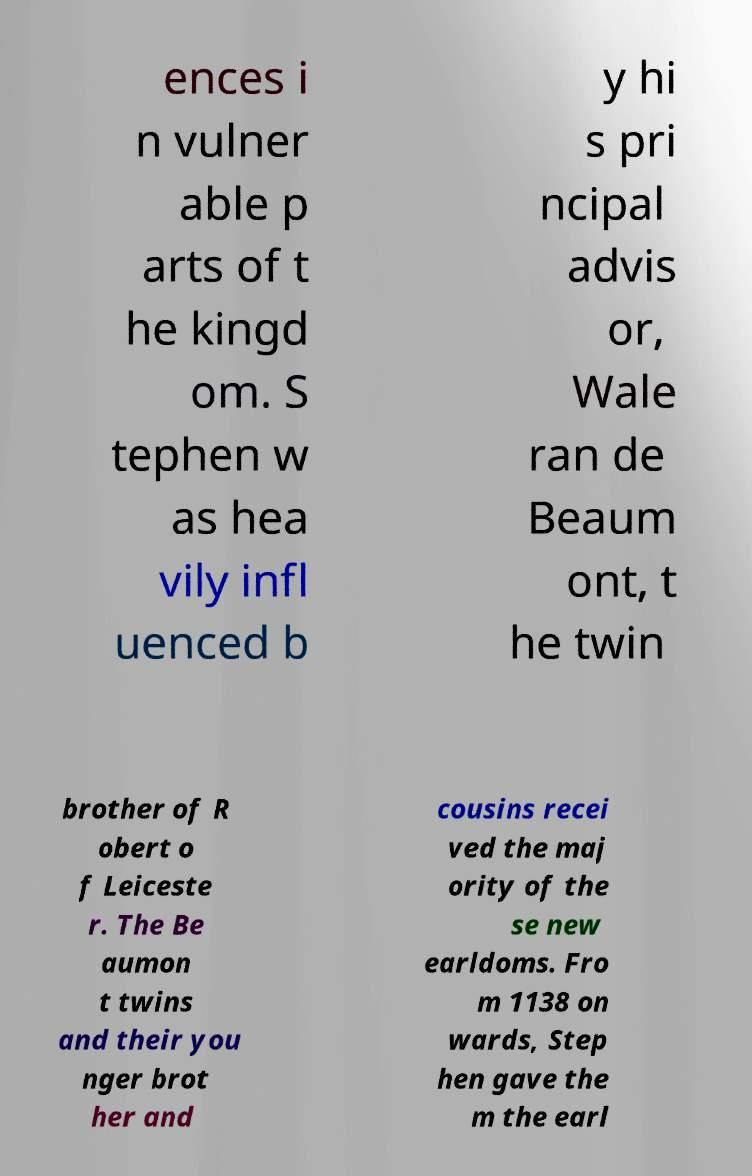I need the written content from this picture converted into text. Can you do that? ences i n vulner able p arts of t he kingd om. S tephen w as hea vily infl uenced b y hi s pri ncipal advis or, Wale ran de Beaum ont, t he twin brother of R obert o f Leiceste r. The Be aumon t twins and their you nger brot her and cousins recei ved the maj ority of the se new earldoms. Fro m 1138 on wards, Step hen gave the m the earl 